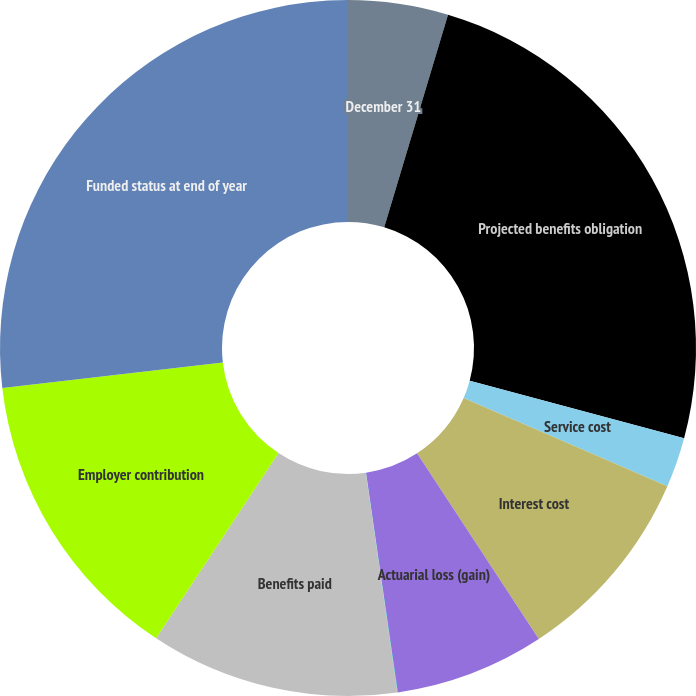Convert chart to OTSL. <chart><loc_0><loc_0><loc_500><loc_500><pie_chart><fcel>December 31<fcel>Projected benefits obligation<fcel>Service cost<fcel>Interest cost<fcel>Actuarial loss (gain)<fcel>Currency translation and other<fcel>Benefits paid<fcel>Employer contribution<fcel>Funded status at end of year<nl><fcel>4.64%<fcel>24.53%<fcel>2.33%<fcel>9.26%<fcel>6.95%<fcel>0.02%<fcel>11.56%<fcel>13.87%<fcel>26.83%<nl></chart> 